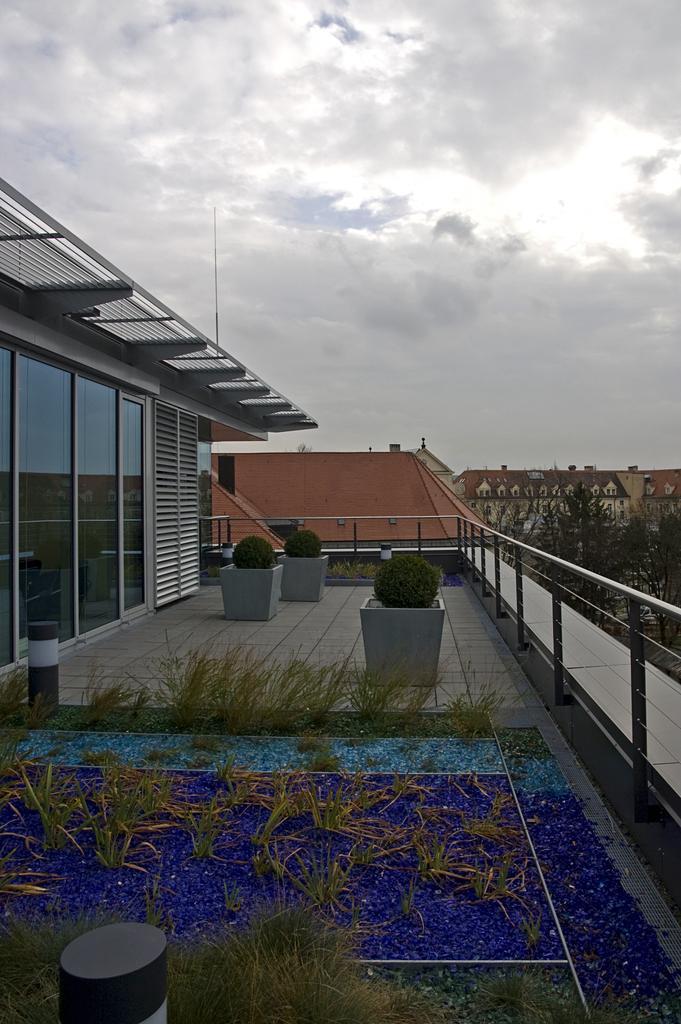How would you summarize this image in a sentence or two? At the bottom of the image we can see some plants on a building. Behind the plants we can see a fencing. Behind the fencing we can see some buildings and trees. At the top of the image we can see some clouds in the sky. 